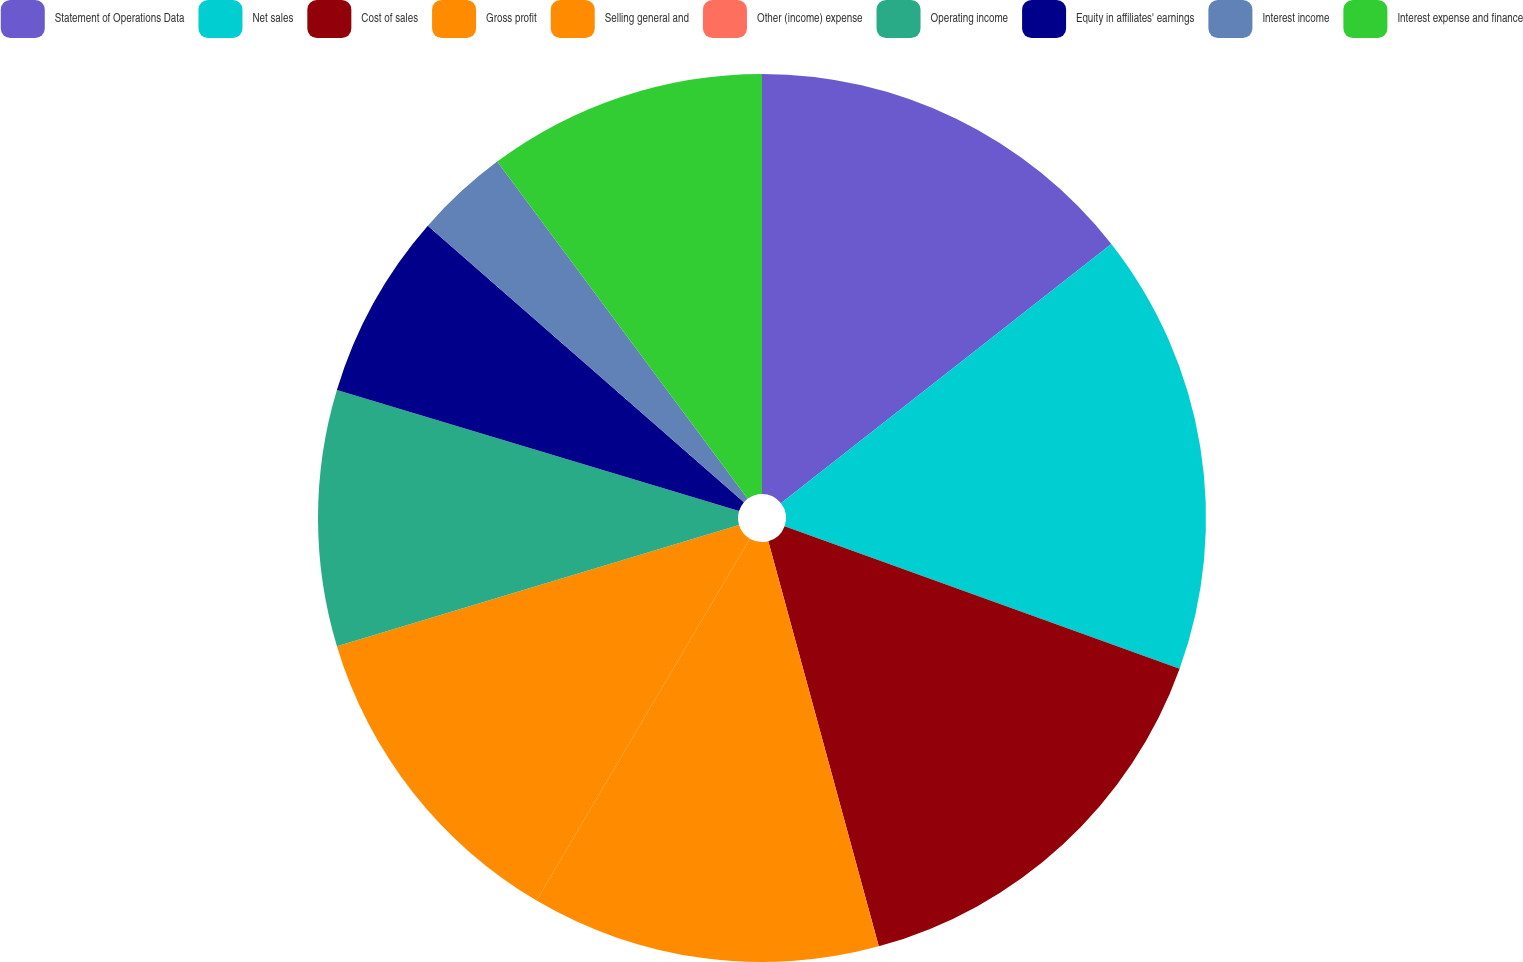Convert chart to OTSL. <chart><loc_0><loc_0><loc_500><loc_500><pie_chart><fcel>Statement of Operations Data<fcel>Net sales<fcel>Cost of sales<fcel>Gross profit<fcel>Selling general and<fcel>Other (income) expense<fcel>Operating income<fcel>Equity in affiliates' earnings<fcel>Interest income<fcel>Interest expense and finance<nl><fcel>14.41%<fcel>16.1%<fcel>15.25%<fcel>12.71%<fcel>11.86%<fcel>0.0%<fcel>9.32%<fcel>6.78%<fcel>3.39%<fcel>10.17%<nl></chart> 